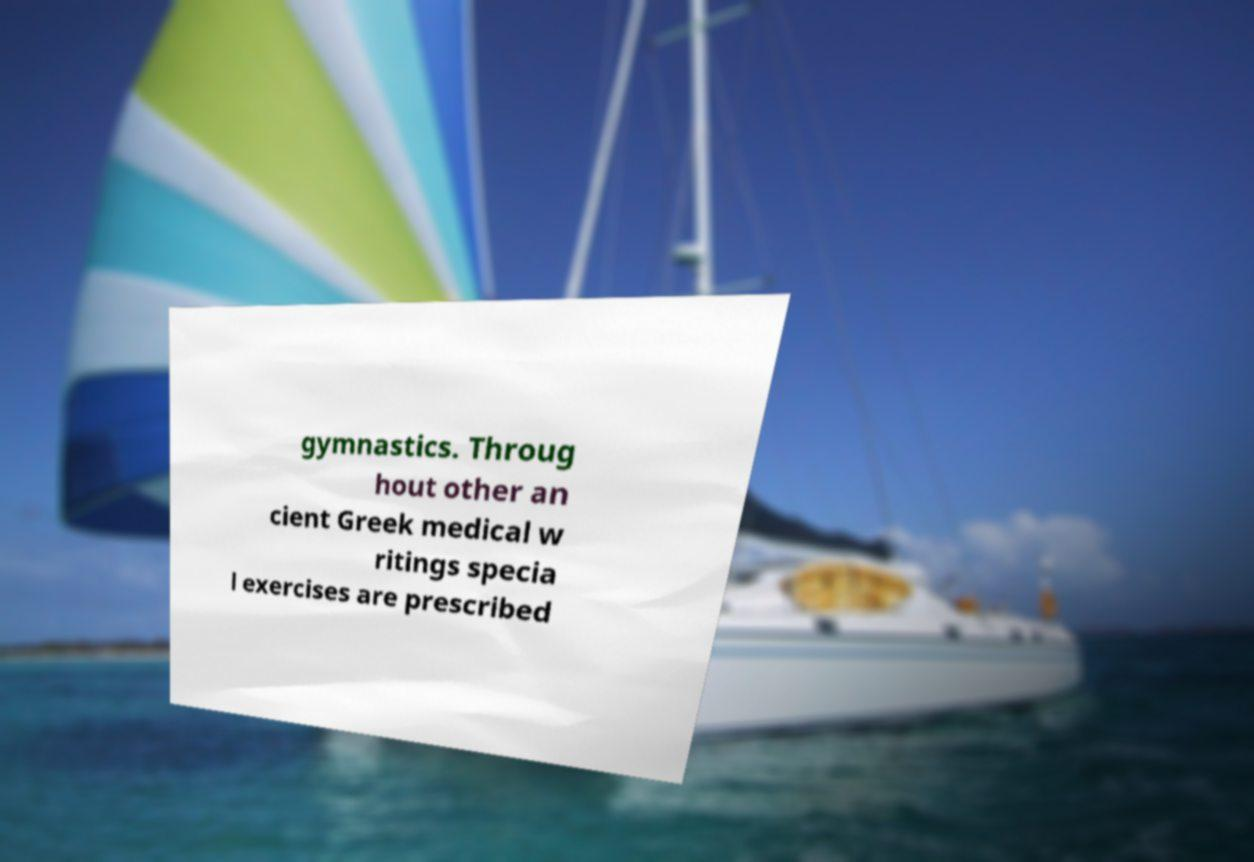I need the written content from this picture converted into text. Can you do that? gymnastics. Throug hout other an cient Greek medical w ritings specia l exercises are prescribed 